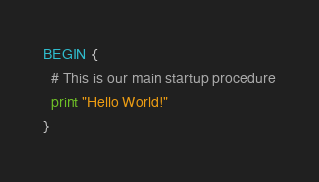<code> <loc_0><loc_0><loc_500><loc_500><_Awk_>BEGIN {
  # This is our main startup procedure
  print "Hello World!"
}
</code> 